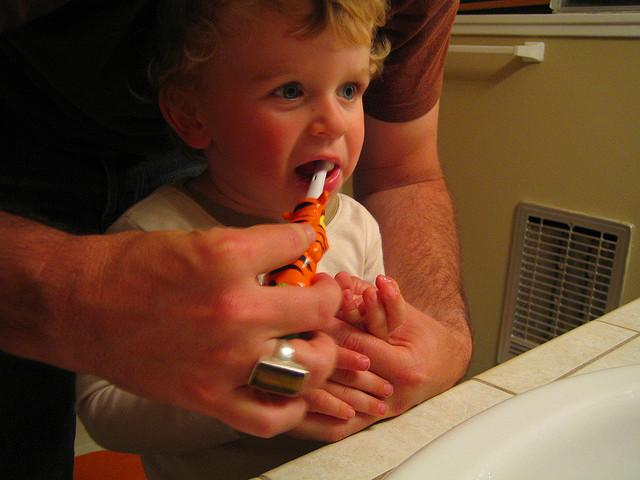What type of animal is the cartoon figure portrayed here based? tiger 